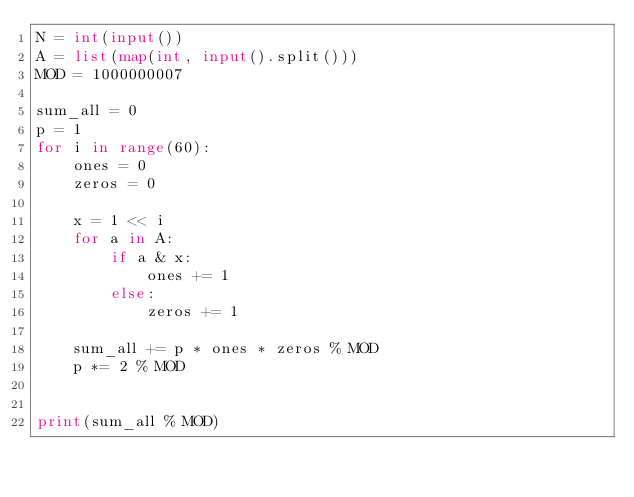Convert code to text. <code><loc_0><loc_0><loc_500><loc_500><_Python_>N = int(input())
A = list(map(int, input().split()))
MOD = 1000000007

sum_all = 0
p = 1
for i in range(60):
    ones = 0
    zeros = 0

    x = 1 << i
    for a in A:
        if a & x:
            ones += 1
        else:
            zeros += 1

    sum_all += p * ones * zeros % MOD
    p *= 2 % MOD


print(sum_all % MOD)
</code> 